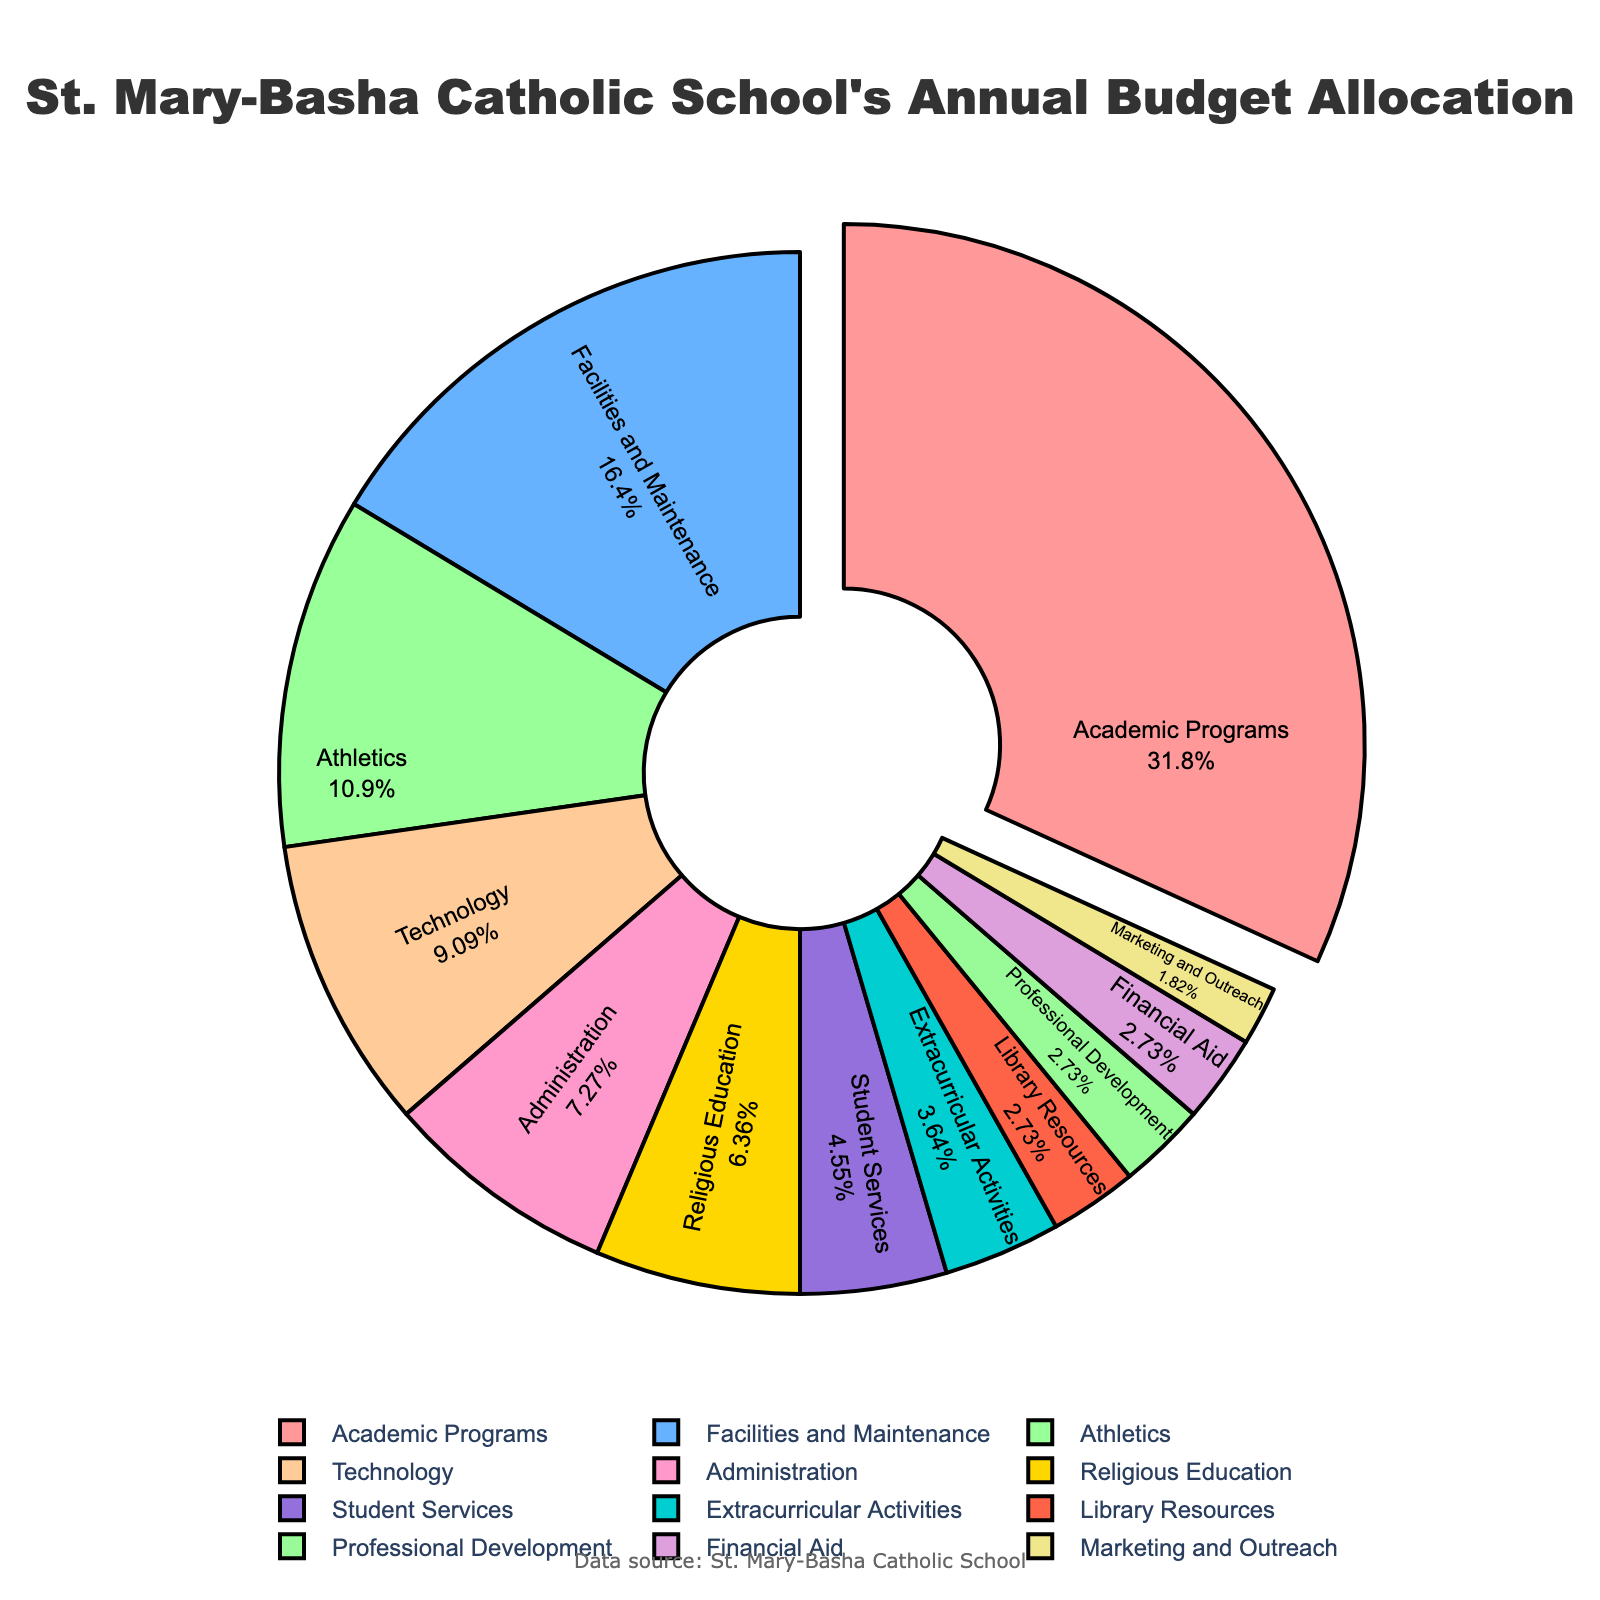What department receives the largest portion of the budget? By examining the pie chart, we can see that the largest slice is pulled out slightly and labeled as "Academic Programs," which accounts for the highest percentage.
Answer: Academic Programs Which two departments together make up exactly 11% of the budget? We look for the departments with percentages that add up to 11%. From the chart, "Student Services" (5%) and "Extracurricular Activities" (4%) combined with "Marketing and Outreach" (2%) make up exactly 11%.
Answer: Student Services and Extracurricular Activities, and Marketing and Outreach How much larger is the budget for Academic Programs compared to Athletics? Academic Programs receive 35% and Athletics receive 12%. The difference is calculated as 35% - 12%.
Answer: 23% Which departments account for less than 5% each? The pie chart shows the percentages for each department. Departments with less than 5% are "Library Resources" (3%), "Professional Development" (3%), "Financial Aid" (3%), and "Marketing and Outreach" (2%).
Answer: Library Resources, Professional Development, Financial Aid, and Marketing and Outreach Do Religious Education and Student Services together account for more or less than the Facilities and Maintenance budget? Adding the percentages of "Religious Education" (7%) and "Student Services" (5%) gives us 12%. "Facilities and Maintenance" is 18%, so 12% is less than 18%.
Answer: Less Which department receives a budget allocation that is color-coded gold? Upon examining the colors in the pie chart, the gold-colored slice corresponds to "Administration."
Answer: Administration What is the percentage difference between Technology and Administration budgets? The chart indicates that Technology accounts for 10% and Administration accounts for 8%. The difference is calculated as 10% - 8%.
Answer: 2% Is the combined budget for Professional Development and Financial Aid equal to the Library Resources budget? Professional Development and Financial Aid each have 3%, summing to 6%. Library Resources is also at 3%. Since 6% is more than 3%, they are not equal.
Answer: No Compare the budget percentages of Technology and Athletics. Which one gets more? From the pie chart, Technology gets 10% and Athletics gets 12%. Therefore, Athletics receives more.
Answer: Athletics If the Athletic budget were increased by 3%, what would be its new percentage and how would it compare to Technology's budget? Athletics is currently 12%. Increasing it by 3% makes it 15%. Since Technology is 10%, Athletics would still be larger than Technology.
Answer: 15%, larger 